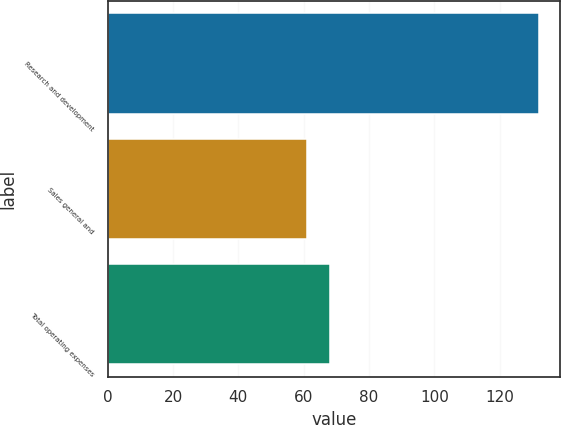Convert chart to OTSL. <chart><loc_0><loc_0><loc_500><loc_500><bar_chart><fcel>Research and development<fcel>Sales general and<fcel>Total operating expenses<nl><fcel>132<fcel>61<fcel>68.1<nl></chart> 